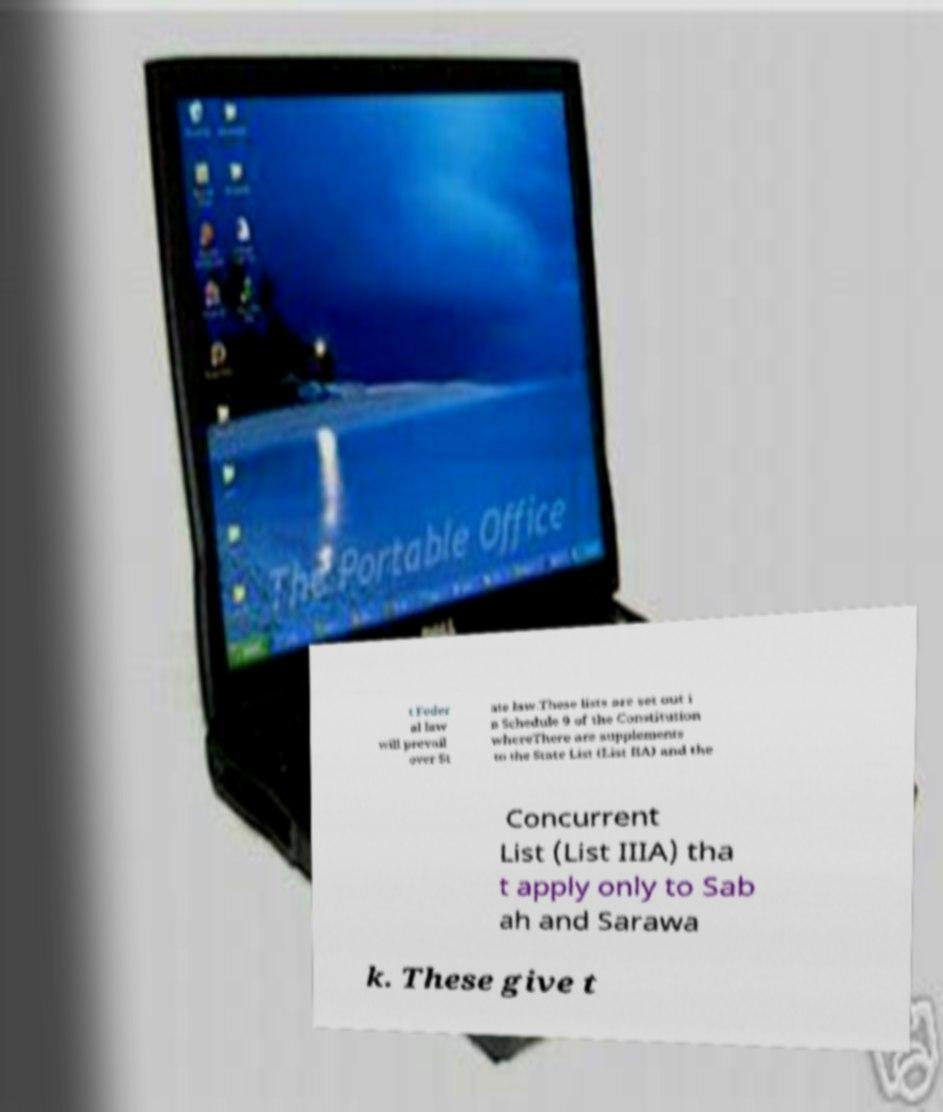Could you assist in decoding the text presented in this image and type it out clearly? t Feder al law will prevail over St ate law.These lists are set out i n Schedule 9 of the Constitution whereThere are supplements to the State List (List IIA) and the Concurrent List (List IIIA) tha t apply only to Sab ah and Sarawa k. These give t 